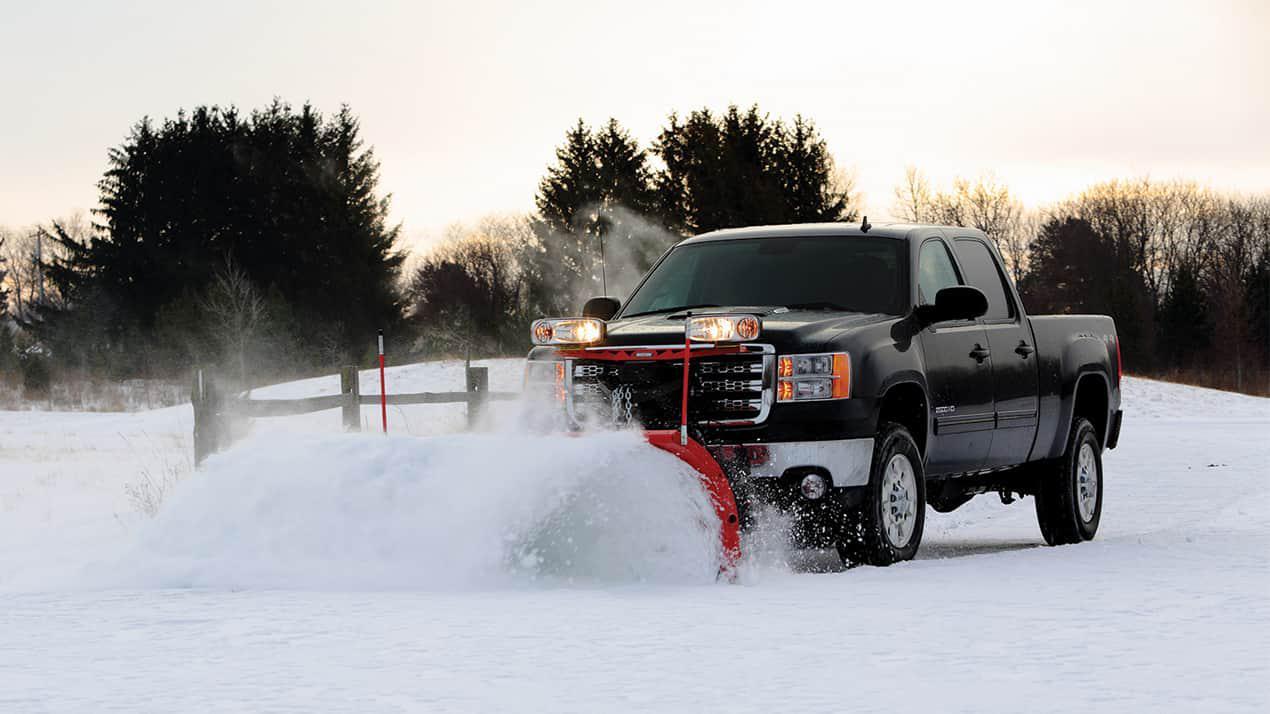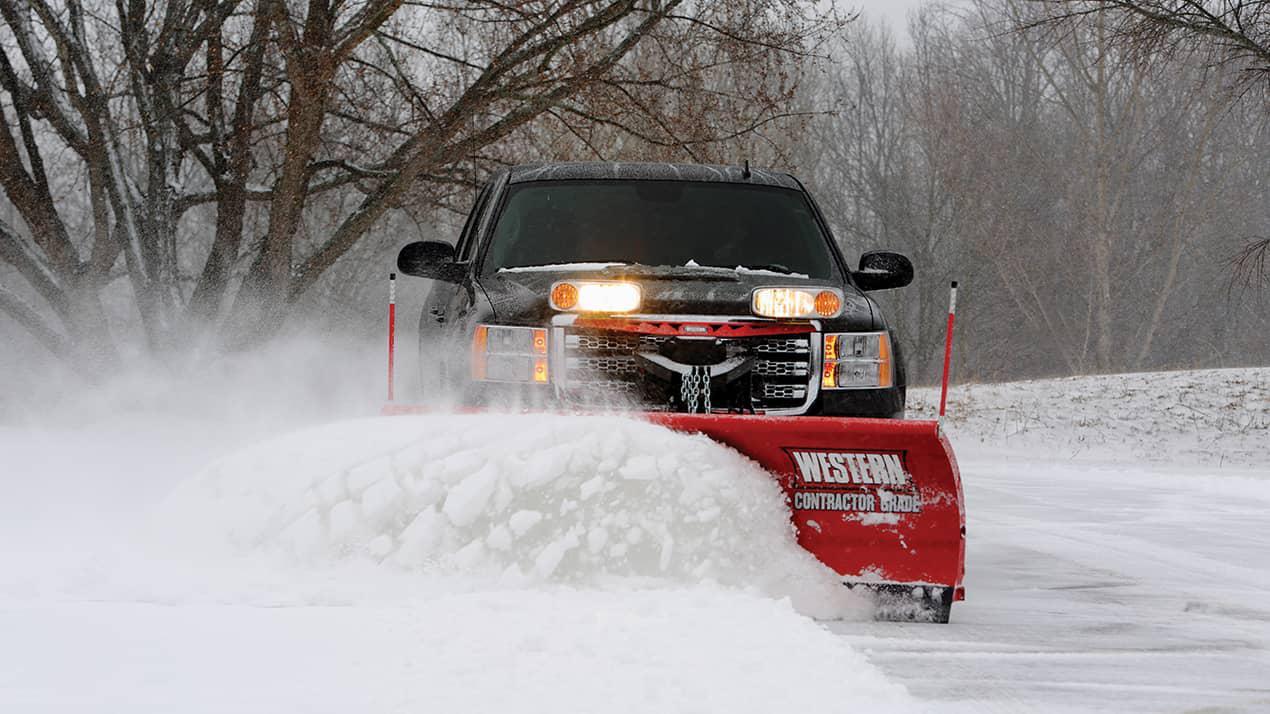The first image is the image on the left, the second image is the image on the right. Examine the images to the left and right. Is the description "The scraper in the image on the left is red." accurate? Answer yes or no. Yes. 